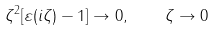<formula> <loc_0><loc_0><loc_500><loc_500>\zeta ^ { 2 } [ \varepsilon ( i \zeta ) - 1 ] \rightarrow 0 , \quad \zeta \rightarrow 0</formula> 